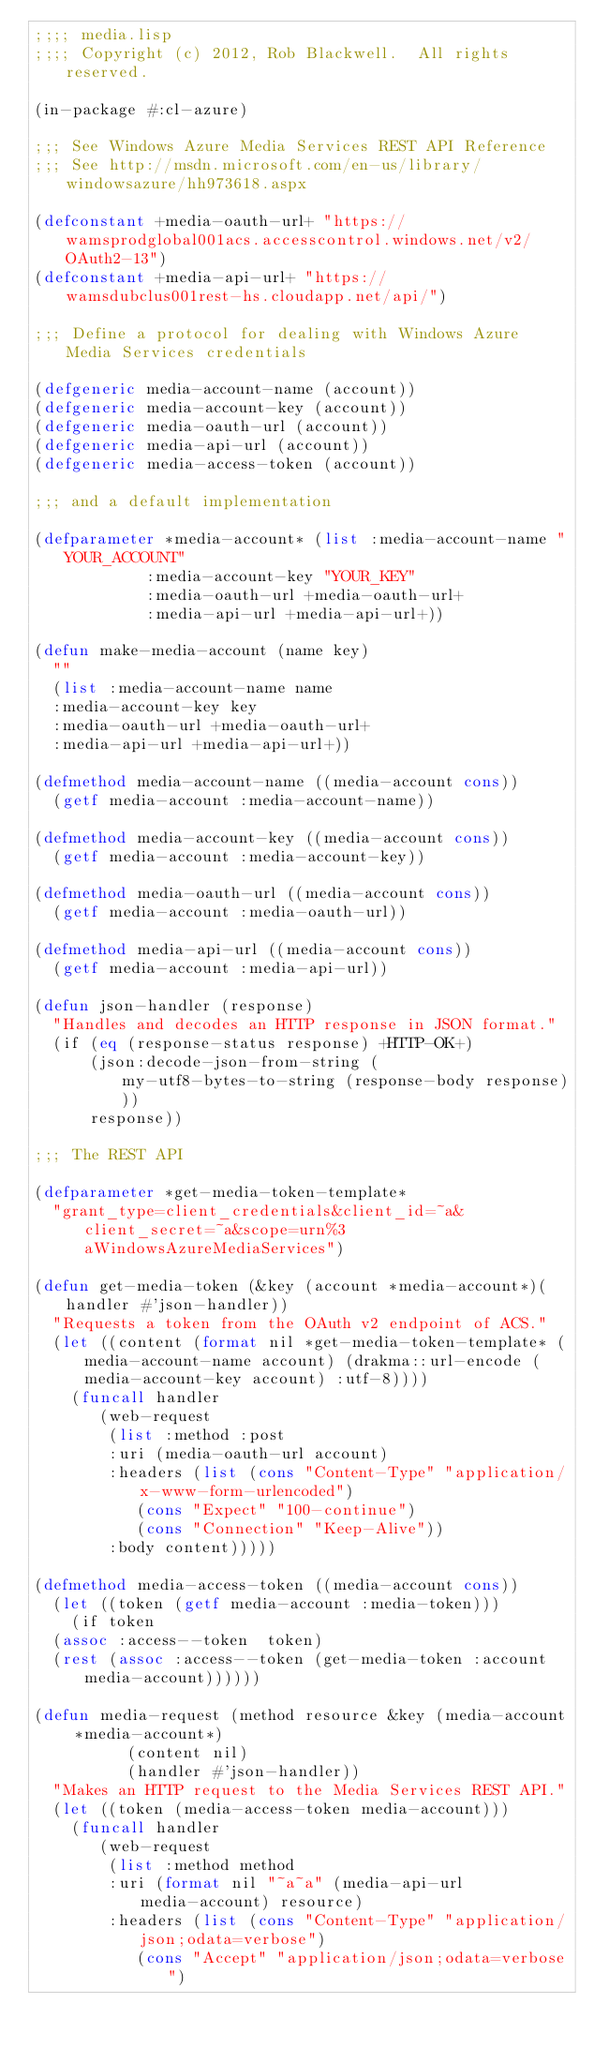<code> <loc_0><loc_0><loc_500><loc_500><_Lisp_>;;;; media.lisp
;;;; Copyright (c) 2012, Rob Blackwell.  All rights reserved.

(in-package #:cl-azure)

;;; See Windows Azure Media Services REST API Reference
;;; See http://msdn.microsoft.com/en-us/library/windowsazure/hh973618.aspx

(defconstant +media-oauth-url+ "https://wamsprodglobal001acs.accesscontrol.windows.net/v2/OAuth2-13")
(defconstant +media-api-url+ "https://wamsdubclus001rest-hs.cloudapp.net/api/")

;;; Define a protocol for dealing with Windows Azure Media Services credentials

(defgeneric media-account-name (account))
(defgeneric media-account-key (account))
(defgeneric media-oauth-url (account))
(defgeneric media-api-url (account))
(defgeneric media-access-token (account))

;;; and a default implementation

(defparameter *media-account* (list :media-account-name "YOUR_ACCOUNT"
				    :media-account-key "YOUR_KEY"
				    :media-oauth-url +media-oauth-url+
				    :media-api-url +media-api-url+))

(defun make-media-account (name key)
  ""
  (list :media-account-name name
	:media-account-key key
	:media-oauth-url +media-oauth-url+
	:media-api-url +media-api-url+))

(defmethod media-account-name ((media-account cons))
  (getf media-account :media-account-name))

(defmethod media-account-key ((media-account cons))
  (getf media-account :media-account-key))

(defmethod media-oauth-url ((media-account cons))
  (getf media-account :media-oauth-url))

(defmethod media-api-url ((media-account cons))
  (getf media-account :media-api-url))

(defun json-handler (response)
  "Handles and decodes an HTTP response in JSON format."
  (if (eq (response-status response) +HTTP-OK+)
      (json:decode-json-from-string (my-utf8-bytes-to-string (response-body response)))
      response))

;;; The REST API

(defparameter *get-media-token-template*
  "grant_type=client_credentials&client_id=~a&client_secret=~a&scope=urn%3aWindowsAzureMediaServices")

(defun get-media-token (&key (account *media-account*)(handler #'json-handler))
  "Requests a token from the OAuth v2 endpoint of ACS."
  (let ((content (format nil *get-media-token-template* (media-account-name account) (drakma::url-encode (media-account-key account) :utf-8))))
    (funcall handler 
	     (web-request
	      (list :method :post
		    :uri (media-oauth-url account)
		    :headers (list (cons "Content-Type" "application/x-www-form-urlencoded")
				   (cons "Expect" "100-continue")
				   (cons "Connection" "Keep-Alive"))
		    :body content)))))

(defmethod media-access-token ((media-account cons))
  (let ((token (getf media-account :media-token)))
    (if token
	(assoc :access--token  token)
	(rest (assoc :access--token (get-media-token :account media-account))))))

(defun media-request (method resource &key (media-account *media-account*) 
		      (content nil) 
		      (handler #'json-handler))
  "Makes an HTTP request to the Media Services REST API."
  (let ((token (media-access-token media-account)))
    (funcall handler
	     (web-request 
	      (list :method method 
		    :uri (format nil "~a~a" (media-api-url media-account) resource)
		    :headers (list (cons "Content-Type" "application/json;odata=verbose")
				   (cons "Accept" "application/json;odata=verbose")</code> 